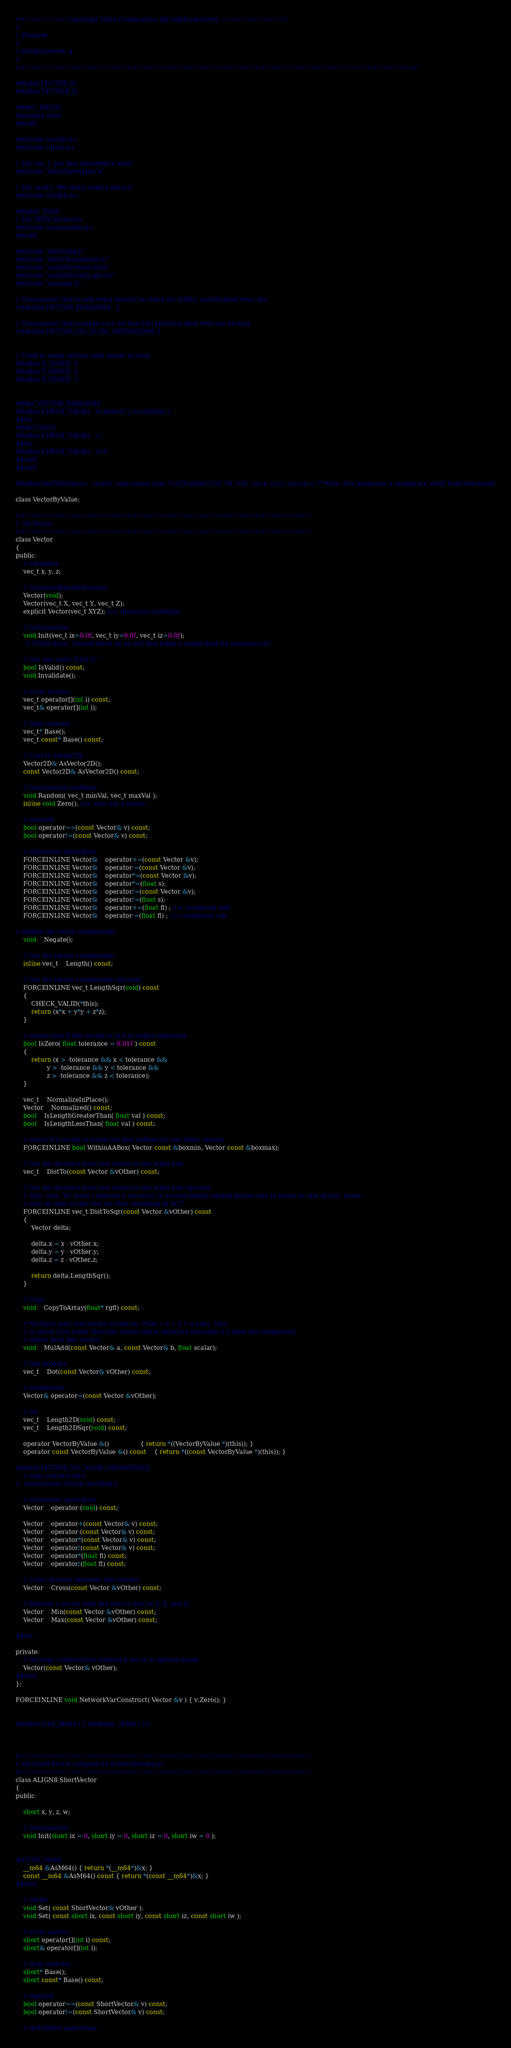<code> <loc_0><loc_0><loc_500><loc_500><_C_>//========= Copyright Valve Corporation, All rights reserved. ============//
//
// Purpose: 
//
// $NoKeywords: $
//
//=============================================================================//

#ifndef VECTOR_H
#define VECTOR_H

#ifdef _WIN32
#pragma once
#endif

#include <math.h>
#include <float.h>

// For vec_t, put this somewhere else?
#include "tier0/basetypes.h"

// For rand(). We really need a library!
#include <stdlib.h>

#ifndef _X360
// For MMX intrinsics
#include <xmmintrin.h>
#endif

#include "tier0/dbg.h"
#include "tier0/threadtools.h"
#include "mathlib/vector2d.h"
#include "mathlib/math_pfns.h"
#include "minmax.h"

// Uncomment this to add extra Asserts to check for NANs, uninitialized vecs, etc.
//#define VECTOR_PARANOIA	1

// Uncomment this to make sure we don't do anything slow with our vectors
//#define VECTOR_NO_SLOW_OPERATIONS 1


// Used to make certain code easier to read.
#define X_INDEX	0
#define Y_INDEX	1
#define Z_INDEX	2


#ifdef VECTOR_PARANOIA
#define CHECK_VALID( _v)	Assert( (_v).IsValid() )
#else
#ifdef GNUC
#define CHECK_VALID( _v)
#else
#define CHECK_VALID( _v)	0
#endif
#endif

#define VecToString(v)	(static_cast<const char *>(CFmtStr("(%f, %f, %f)", (v).x, (v).y, (v).z))) // ** Note: this generates a temporary, don't hold reference!

class VectorByValue;

//=========================================================
// 3D Vector
//=========================================================
class Vector					
{
public:
	// Members
	vec_t x, y, z;

	// Construction/destruction:
	Vector(void); 
	Vector(vec_t X, vec_t Y, vec_t Z);
	explicit Vector(vec_t XYZ); ///< broadcast initialize

	// Initialization
	void Init(vec_t ix=0.0f, vec_t iy=0.0f, vec_t iz=0.0f);
	 // TODO (Ilya): Should there be an init that takes a single float for consistency?

	// Got any nasty NAN's?
	bool IsValid() const;
	void Invalidate();

	// array access...
	vec_t operator[](int i) const;
	vec_t& operator[](int i);

	// Base address...
	vec_t* Base();
	vec_t const* Base() const;

	// Cast to Vector2D...
	Vector2D& AsVector2D();
	const Vector2D& AsVector2D() const;

	// Initialization methods
	void Random( vec_t minVal, vec_t maxVal );
	inline void Zero(); ///< zero out a vector

	// equality
	bool operator==(const Vector& v) const;
	bool operator!=(const Vector& v) const;	

	// arithmetic operations
	FORCEINLINE Vector&	operator+=(const Vector &v);			
	FORCEINLINE Vector&	operator-=(const Vector &v);		
	FORCEINLINE Vector&	operator*=(const Vector &v);			
	FORCEINLINE Vector&	operator*=(float s);
	FORCEINLINE Vector&	operator/=(const Vector &v);		
	FORCEINLINE Vector&	operator/=(float s);	
	FORCEINLINE Vector&	operator+=(float fl) ; ///< broadcast add
	FORCEINLINE Vector&	operator-=(float fl) ; ///< broadcast sub			

// negate the vector components
	void	Negate(); 

	// Get the vector's magnitude.
	inline vec_t	Length() const;

	// Get the vector's magnitude squared.
	FORCEINLINE vec_t LengthSqr(void) const
	{ 
		CHECK_VALID(*this);
		return (x*x + y*y + z*z);		
	}

	// return true if this vector is (0,0,0) within tolerance
	bool IsZero( float tolerance = 0.01f ) const
	{
		return (x > -tolerance && x < tolerance &&
				y > -tolerance && y < tolerance &&
				z > -tolerance && z < tolerance);
	}

	vec_t	NormalizeInPlace();
	Vector	Normalized() const;
	bool	IsLengthGreaterThan( float val ) const;
	bool	IsLengthLessThan( float val ) const;

	// check if a vector is within the box defined by two other vectors
	FORCEINLINE bool WithinAABox( Vector const &boxmin, Vector const &boxmax);
 
	// Get the distance from this vector to the other one.
	vec_t	DistTo(const Vector &vOther) const;

	// Get the distance from this vector to the other one squared.
	// NJS: note, VC wasn't inlining it correctly in several deeply nested inlines due to being an 'out of line' inline.  
	// may be able to tidy this up after switching to VC7
	FORCEINLINE vec_t DistToSqr(const Vector &vOther) const
	{
		Vector delta;

		delta.x = x - vOther.x;
		delta.y = y - vOther.y;
		delta.z = z - vOther.z;

		return delta.LengthSqr();
	}

	// Copy
	void	CopyToArray(float* rgfl) const;	

	// Multiply, add, and assign to this (ie: *this = a + b * scalar). This
	// is about 12% faster than the actual vector equation (because it's done per-component
	// rather than per-vector).
	void	MulAdd(const Vector& a, const Vector& b, float scalar);	

	// Dot product.
	vec_t	Dot(const Vector& vOther) const;			

	// assignment
	Vector& operator=(const Vector &vOther);

	// 2d
	vec_t	Length2D(void) const;					
	vec_t	Length2DSqr(void) const;					

	operator VectorByValue &()				{ return *((VectorByValue *)(this)); }
	operator const VectorByValue &() const	{ return *((const VectorByValue *)(this)); }

#ifndef VECTOR_NO_SLOW_OPERATIONS
	// copy constructors
//	Vector(const Vector &vOther);

	// arithmetic operations
	Vector	operator-(void) const;
				
	Vector	operator+(const Vector& v) const;	
	Vector	operator-(const Vector& v) const;	
	Vector	operator*(const Vector& v) const;	
	Vector	operator/(const Vector& v) const;	
	Vector	operator*(float fl) const;
	Vector	operator/(float fl) const;			
	
	// Cross product between two vectors.
	Vector	Cross(const Vector &vOther) const;		

	// Returns a vector with the min or max in X, Y, and Z.
	Vector	Min(const Vector &vOther) const;
	Vector	Max(const Vector &vOther) const;

#else

private:
	// No copy constructors allowed if we're in optimal mode
	Vector(const Vector& vOther);
#endif
};

FORCEINLINE void NetworkVarConstruct( Vector &v ) { v.Zero(); }


#define USE_M64S ( ( !defined( _X360 ) ) )



//=========================================================
// 4D Short Vector (aligned on 8-byte boundary)
//=========================================================
class ALIGN8 ShortVector
{
public:

	short x, y, z, w;

	// Initialization
	void Init(short ix = 0, short iy = 0, short iz = 0, short iw = 0 );


#if USE_M64S
	__m64 &AsM64() { return *(__m64*)&x; }
	const __m64 &AsM64() const { return *(const __m64*)&x; } 
#endif

	// Setter
	void Set( const ShortVector& vOther );
	void Set( const short ix, const short iy, const short iz, const short iw );

	// array access...
	short operator[](int i) const;
	short& operator[](int i);

	// Base address...
	short* Base();
	short const* Base() const;

	// equality
	bool operator==(const ShortVector& v) const;
	bool operator!=(const ShortVector& v) const;	

	// Arithmetic operations</code> 